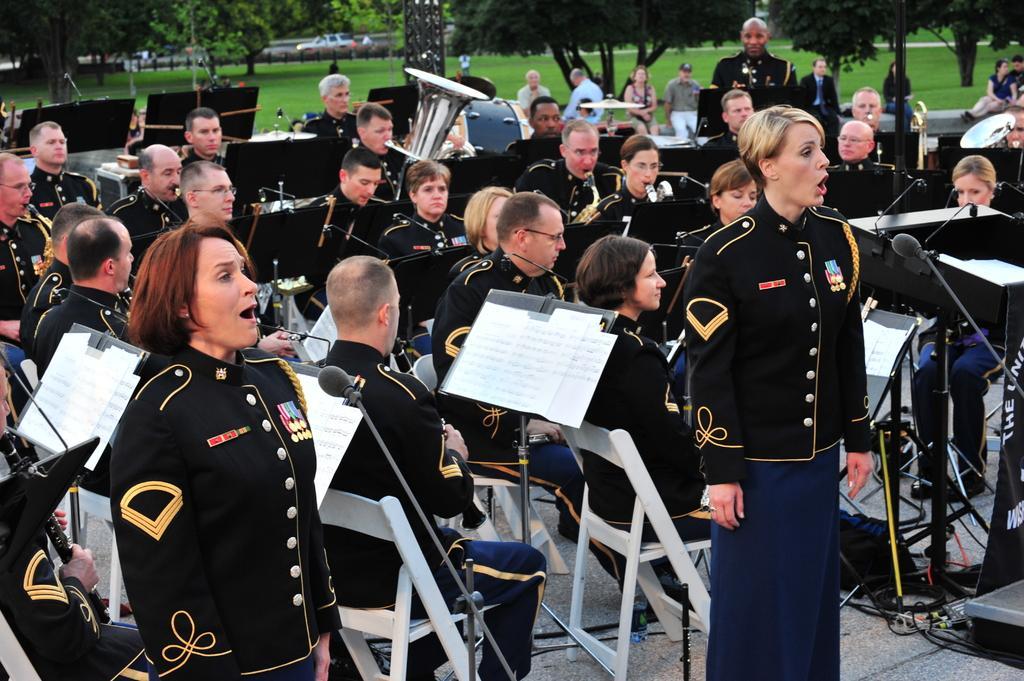How would you summarize this image in a sentence or two? In this image there are there are the group of people sitting on the chair and wearing a black color skirt and they both mouth was open an they are playing a music in front of the mike. there are some audience listen to the music. backside there are some trees and there is a grass and there is a vehicle on the road. there are some musical instrument kept on the right side. 